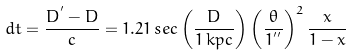<formula> <loc_0><loc_0><loc_500><loc_500>d t = \frac { D ^ { ^ { \prime } } - D } { c } = 1 . 2 1 \, s e c \left ( \frac { D } { 1 \, k p c } \right ) \left ( \frac { \theta } { 1 ^ { ^ { \prime \prime } } } \right ) ^ { 2 } \frac { x } { 1 - x }</formula> 